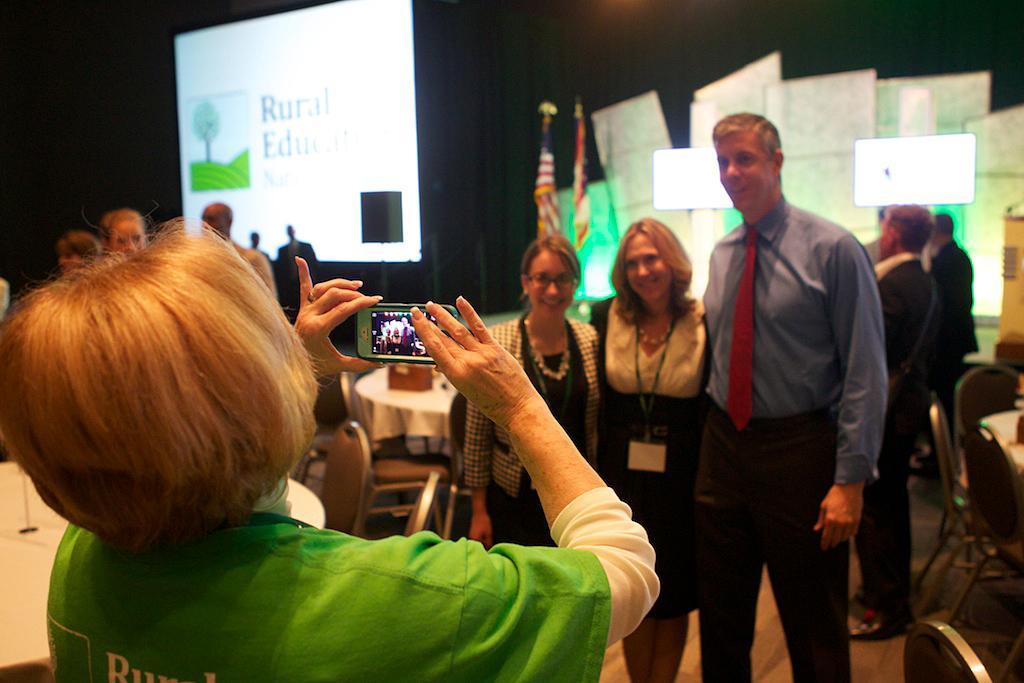Describe this image in one or two sentences. In this image we can see a woman holding the mobile phone and capturing the photograph of two women and a man and these three people are standing on the floor and smiling. In the background we can see the screen for displaying. We can also see the small screens, flags, podium and also the banners. We can also see the tables with chairs. On the left we can see a few people in the background. 